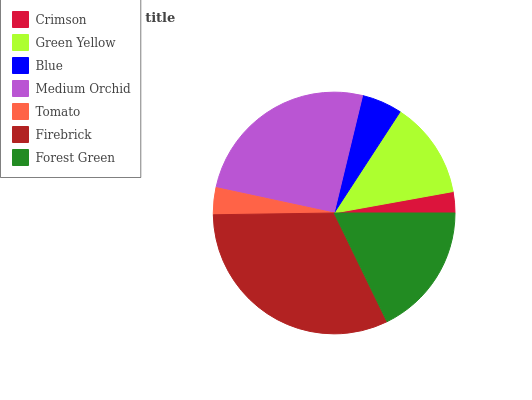Is Crimson the minimum?
Answer yes or no. Yes. Is Firebrick the maximum?
Answer yes or no. Yes. Is Green Yellow the minimum?
Answer yes or no. No. Is Green Yellow the maximum?
Answer yes or no. No. Is Green Yellow greater than Crimson?
Answer yes or no. Yes. Is Crimson less than Green Yellow?
Answer yes or no. Yes. Is Crimson greater than Green Yellow?
Answer yes or no. No. Is Green Yellow less than Crimson?
Answer yes or no. No. Is Green Yellow the high median?
Answer yes or no. Yes. Is Green Yellow the low median?
Answer yes or no. Yes. Is Crimson the high median?
Answer yes or no. No. Is Tomato the low median?
Answer yes or no. No. 